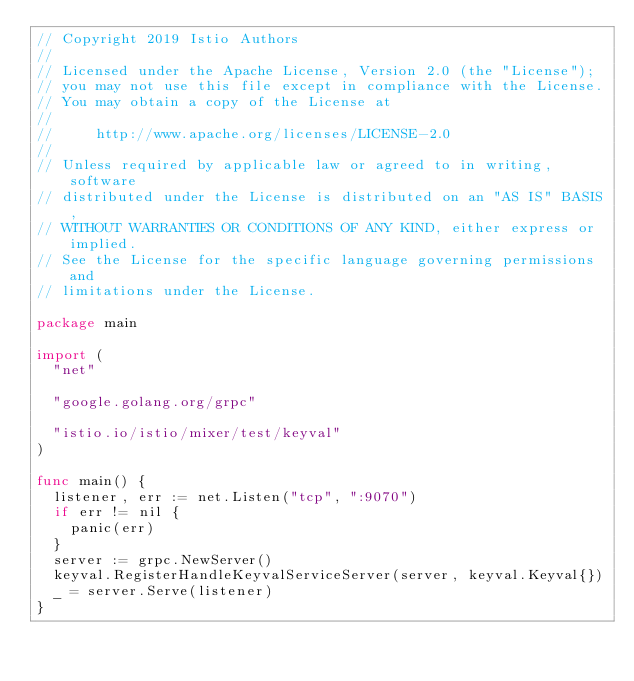<code> <loc_0><loc_0><loc_500><loc_500><_Go_>// Copyright 2019 Istio Authors
//
// Licensed under the Apache License, Version 2.0 (the "License");
// you may not use this file except in compliance with the License.
// You may obtain a copy of the License at
//
//     http://www.apache.org/licenses/LICENSE-2.0
//
// Unless required by applicable law or agreed to in writing, software
// distributed under the License is distributed on an "AS IS" BASIS,
// WITHOUT WARRANTIES OR CONDITIONS OF ANY KIND, either express or implied.
// See the License for the specific language governing permissions and
// limitations under the License.

package main

import (
	"net"

	"google.golang.org/grpc"

	"istio.io/istio/mixer/test/keyval"
)

func main() {
	listener, err := net.Listen("tcp", ":9070")
	if err != nil {
		panic(err)
	}
	server := grpc.NewServer()
	keyval.RegisterHandleKeyvalServiceServer(server, keyval.Keyval{})
	_ = server.Serve(listener)
}
</code> 